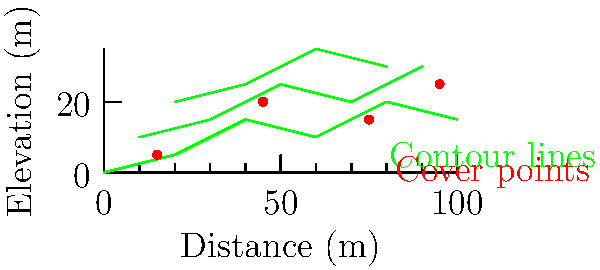Based on the topographic map provided, which firing position offers the best combination of elevation advantage and cover for a long-range engagement? Assume the target is located at coordinates $(100, 15)$. To determine the optimal firing position, we need to consider several factors:

1. Elevation: Higher positions generally provide better visibility and firing angles.
2. Cover: Positions near cover points offer protection and concealment.
3. Distance to target: Balancing elevation and range is crucial for accuracy.

Let's analyze the available positions:

1. $(15, 5)$: Low elevation, good cover, but far from the target.
2. $(45, 20)$: Good elevation, excellent cover, moderate distance to target.
3. $(75, 15)$: Moderate elevation, good cover, closer to the target.
4. $(95, 25)$: Highest elevation, good cover, closest to the target.

Comparing these options:

- Position $(15, 5)$ is too low and far for an optimal engagement.
- Position $(45, 20)$ offers a good balance of elevation and cover but is farther from the target.
- Position $(75, 15)$ has moderate elevation but is closer to the target.
- Position $(95, 25)$ provides the highest elevation, good cover, and is closest to the target.

The optimal firing position should maximize the elevation advantage while maintaining adequate cover and a reasonable distance to the target. In this case, position $(95, 25)$ offers the best combination of these factors.
Answer: $(95, 25)$ 